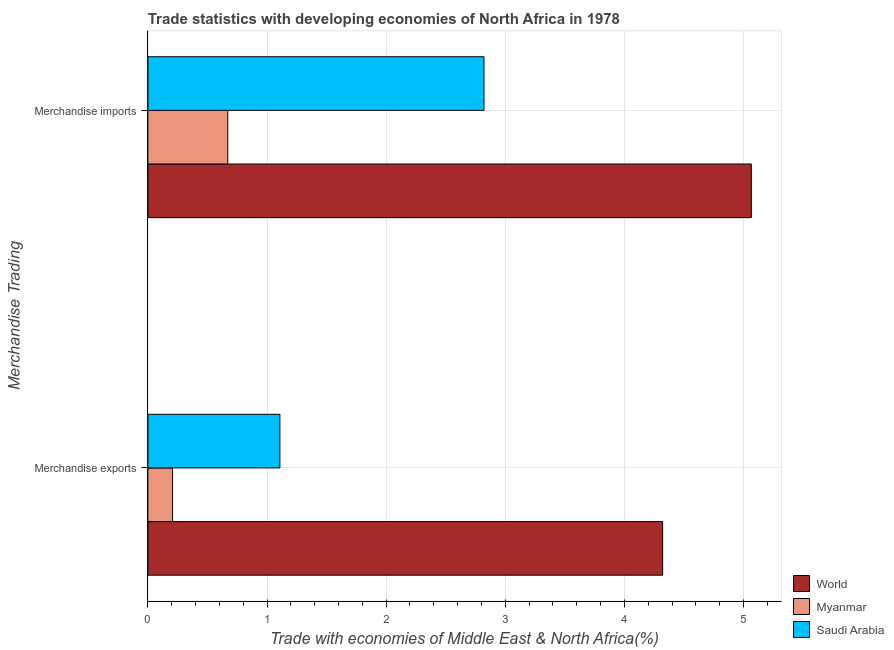Are the number of bars per tick equal to the number of legend labels?
Your response must be concise. Yes. Are the number of bars on each tick of the Y-axis equal?
Keep it short and to the point. Yes. How many bars are there on the 1st tick from the top?
Offer a terse response. 3. What is the merchandise imports in World?
Provide a succinct answer. 5.07. Across all countries, what is the maximum merchandise imports?
Offer a very short reply. 5.07. Across all countries, what is the minimum merchandise exports?
Your response must be concise. 0.21. In which country was the merchandise imports maximum?
Offer a terse response. World. In which country was the merchandise exports minimum?
Keep it short and to the point. Myanmar. What is the total merchandise imports in the graph?
Your response must be concise. 8.56. What is the difference between the merchandise exports in Saudi Arabia and that in Myanmar?
Make the answer very short. 0.9. What is the difference between the merchandise exports in Saudi Arabia and the merchandise imports in World?
Your response must be concise. -3.96. What is the average merchandise imports per country?
Your answer should be very brief. 2.85. What is the difference between the merchandise imports and merchandise exports in World?
Offer a very short reply. 0.74. What is the ratio of the merchandise exports in Saudi Arabia to that in World?
Keep it short and to the point. 0.26. In how many countries, is the merchandise imports greater than the average merchandise imports taken over all countries?
Provide a succinct answer. 1. What does the 2nd bar from the bottom in Merchandise exports represents?
Your answer should be very brief. Myanmar. Are all the bars in the graph horizontal?
Provide a short and direct response. Yes. Where does the legend appear in the graph?
Keep it short and to the point. Bottom right. How are the legend labels stacked?
Provide a short and direct response. Vertical. What is the title of the graph?
Your response must be concise. Trade statistics with developing economies of North Africa in 1978. What is the label or title of the X-axis?
Provide a succinct answer. Trade with economies of Middle East & North Africa(%). What is the label or title of the Y-axis?
Give a very brief answer. Merchandise Trading. What is the Trade with economies of Middle East & North Africa(%) in World in Merchandise exports?
Provide a short and direct response. 4.32. What is the Trade with economies of Middle East & North Africa(%) of Myanmar in Merchandise exports?
Ensure brevity in your answer.  0.21. What is the Trade with economies of Middle East & North Africa(%) of Saudi Arabia in Merchandise exports?
Provide a short and direct response. 1.11. What is the Trade with economies of Middle East & North Africa(%) of World in Merchandise imports?
Provide a short and direct response. 5.07. What is the Trade with economies of Middle East & North Africa(%) in Myanmar in Merchandise imports?
Keep it short and to the point. 0.67. What is the Trade with economies of Middle East & North Africa(%) of Saudi Arabia in Merchandise imports?
Give a very brief answer. 2.82. Across all Merchandise Trading, what is the maximum Trade with economies of Middle East & North Africa(%) of World?
Keep it short and to the point. 5.07. Across all Merchandise Trading, what is the maximum Trade with economies of Middle East & North Africa(%) in Myanmar?
Give a very brief answer. 0.67. Across all Merchandise Trading, what is the maximum Trade with economies of Middle East & North Africa(%) in Saudi Arabia?
Offer a terse response. 2.82. Across all Merchandise Trading, what is the minimum Trade with economies of Middle East & North Africa(%) of World?
Offer a terse response. 4.32. Across all Merchandise Trading, what is the minimum Trade with economies of Middle East & North Africa(%) in Myanmar?
Your answer should be compact. 0.21. Across all Merchandise Trading, what is the minimum Trade with economies of Middle East & North Africa(%) of Saudi Arabia?
Provide a succinct answer. 1.11. What is the total Trade with economies of Middle East & North Africa(%) in World in the graph?
Ensure brevity in your answer.  9.39. What is the total Trade with economies of Middle East & North Africa(%) of Myanmar in the graph?
Your response must be concise. 0.88. What is the total Trade with economies of Middle East & North Africa(%) of Saudi Arabia in the graph?
Your response must be concise. 3.93. What is the difference between the Trade with economies of Middle East & North Africa(%) in World in Merchandise exports and that in Merchandise imports?
Your answer should be very brief. -0.74. What is the difference between the Trade with economies of Middle East & North Africa(%) in Myanmar in Merchandise exports and that in Merchandise imports?
Provide a short and direct response. -0.46. What is the difference between the Trade with economies of Middle East & North Africa(%) in Saudi Arabia in Merchandise exports and that in Merchandise imports?
Provide a short and direct response. -1.71. What is the difference between the Trade with economies of Middle East & North Africa(%) of World in Merchandise exports and the Trade with economies of Middle East & North Africa(%) of Myanmar in Merchandise imports?
Your answer should be compact. 3.65. What is the difference between the Trade with economies of Middle East & North Africa(%) in World in Merchandise exports and the Trade with economies of Middle East & North Africa(%) in Saudi Arabia in Merchandise imports?
Give a very brief answer. 1.5. What is the difference between the Trade with economies of Middle East & North Africa(%) of Myanmar in Merchandise exports and the Trade with economies of Middle East & North Africa(%) of Saudi Arabia in Merchandise imports?
Offer a terse response. -2.61. What is the average Trade with economies of Middle East & North Africa(%) in World per Merchandise Trading?
Your answer should be compact. 4.69. What is the average Trade with economies of Middle East & North Africa(%) of Myanmar per Merchandise Trading?
Ensure brevity in your answer.  0.44. What is the average Trade with economies of Middle East & North Africa(%) of Saudi Arabia per Merchandise Trading?
Give a very brief answer. 1.96. What is the difference between the Trade with economies of Middle East & North Africa(%) in World and Trade with economies of Middle East & North Africa(%) in Myanmar in Merchandise exports?
Your answer should be very brief. 4.11. What is the difference between the Trade with economies of Middle East & North Africa(%) of World and Trade with economies of Middle East & North Africa(%) of Saudi Arabia in Merchandise exports?
Your response must be concise. 3.21. What is the difference between the Trade with economies of Middle East & North Africa(%) of Myanmar and Trade with economies of Middle East & North Africa(%) of Saudi Arabia in Merchandise exports?
Offer a terse response. -0.9. What is the difference between the Trade with economies of Middle East & North Africa(%) of World and Trade with economies of Middle East & North Africa(%) of Myanmar in Merchandise imports?
Your answer should be very brief. 4.39. What is the difference between the Trade with economies of Middle East & North Africa(%) in World and Trade with economies of Middle East & North Africa(%) in Saudi Arabia in Merchandise imports?
Keep it short and to the point. 2.24. What is the difference between the Trade with economies of Middle East & North Africa(%) of Myanmar and Trade with economies of Middle East & North Africa(%) of Saudi Arabia in Merchandise imports?
Ensure brevity in your answer.  -2.15. What is the ratio of the Trade with economies of Middle East & North Africa(%) of World in Merchandise exports to that in Merchandise imports?
Make the answer very short. 0.85. What is the ratio of the Trade with economies of Middle East & North Africa(%) in Myanmar in Merchandise exports to that in Merchandise imports?
Keep it short and to the point. 0.31. What is the ratio of the Trade with economies of Middle East & North Africa(%) of Saudi Arabia in Merchandise exports to that in Merchandise imports?
Provide a short and direct response. 0.39. What is the difference between the highest and the second highest Trade with economies of Middle East & North Africa(%) of World?
Make the answer very short. 0.74. What is the difference between the highest and the second highest Trade with economies of Middle East & North Africa(%) in Myanmar?
Ensure brevity in your answer.  0.46. What is the difference between the highest and the second highest Trade with economies of Middle East & North Africa(%) of Saudi Arabia?
Provide a short and direct response. 1.71. What is the difference between the highest and the lowest Trade with economies of Middle East & North Africa(%) in World?
Offer a very short reply. 0.74. What is the difference between the highest and the lowest Trade with economies of Middle East & North Africa(%) in Myanmar?
Your answer should be compact. 0.46. What is the difference between the highest and the lowest Trade with economies of Middle East & North Africa(%) of Saudi Arabia?
Keep it short and to the point. 1.71. 